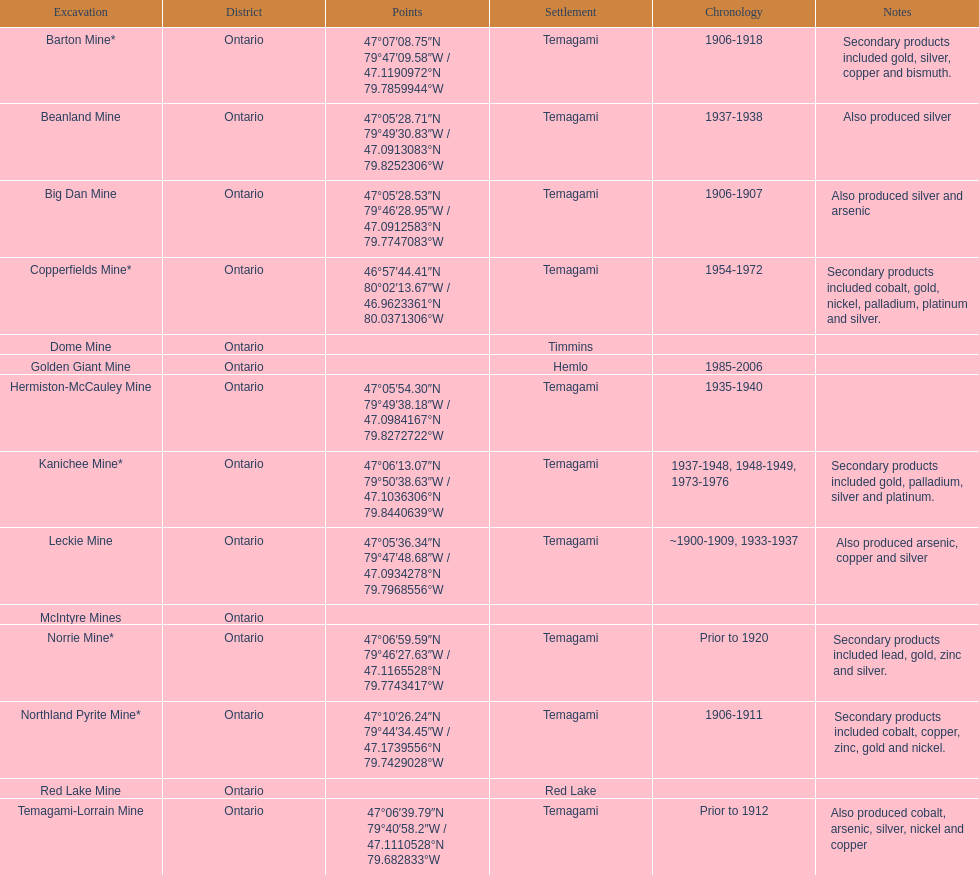Give me the full table as a dictionary. {'header': ['Excavation', 'District', 'Points', 'Settlement', 'Chronology', 'Notes'], 'rows': [['Barton Mine*', 'Ontario', '47°07′08.75″N 79°47′09.58″W\ufeff / \ufeff47.1190972°N 79.7859944°W', 'Temagami', '1906-1918', 'Secondary products included gold, silver, copper and bismuth.'], ['Beanland Mine', 'Ontario', '47°05′28.71″N 79°49′30.83″W\ufeff / \ufeff47.0913083°N 79.8252306°W', 'Temagami', '1937-1938', 'Also produced silver'], ['Big Dan Mine', 'Ontario', '47°05′28.53″N 79°46′28.95″W\ufeff / \ufeff47.0912583°N 79.7747083°W', 'Temagami', '1906-1907', 'Also produced silver and arsenic'], ['Copperfields Mine*', 'Ontario', '46°57′44.41″N 80°02′13.67″W\ufeff / \ufeff46.9623361°N 80.0371306°W', 'Temagami', '1954-1972', 'Secondary products included cobalt, gold, nickel, palladium, platinum and silver.'], ['Dome Mine', 'Ontario', '', 'Timmins', '', ''], ['Golden Giant Mine', 'Ontario', '', 'Hemlo', '1985-2006', ''], ['Hermiston-McCauley Mine', 'Ontario', '47°05′54.30″N 79°49′38.18″W\ufeff / \ufeff47.0984167°N 79.8272722°W', 'Temagami', '1935-1940', ''], ['Kanichee Mine*', 'Ontario', '47°06′13.07″N 79°50′38.63″W\ufeff / \ufeff47.1036306°N 79.8440639°W', 'Temagami', '1937-1948, 1948-1949, 1973-1976', 'Secondary products included gold, palladium, silver and platinum.'], ['Leckie Mine', 'Ontario', '47°05′36.34″N 79°47′48.68″W\ufeff / \ufeff47.0934278°N 79.7968556°W', 'Temagami', '~1900-1909, 1933-1937', 'Also produced arsenic, copper and silver'], ['McIntyre Mines', 'Ontario', '', '', '', ''], ['Norrie Mine*', 'Ontario', '47°06′59.59″N 79°46′27.63″W\ufeff / \ufeff47.1165528°N 79.7743417°W', 'Temagami', 'Prior to 1920', 'Secondary products included lead, gold, zinc and silver.'], ['Northland Pyrite Mine*', 'Ontario', '47°10′26.24″N 79°44′34.45″W\ufeff / \ufeff47.1739556°N 79.7429028°W', 'Temagami', '1906-1911', 'Secondary products included cobalt, copper, zinc, gold and nickel.'], ['Red Lake Mine', 'Ontario', '', 'Red Lake', '', ''], ['Temagami-Lorrain Mine', 'Ontario', '47°06′39.79″N 79°40′58.2″W\ufeff / \ufeff47.1110528°N 79.682833°W', 'Temagami', 'Prior to 1912', 'Also produced cobalt, arsenic, silver, nickel and copper']]} What town is listed the most? Temagami. 